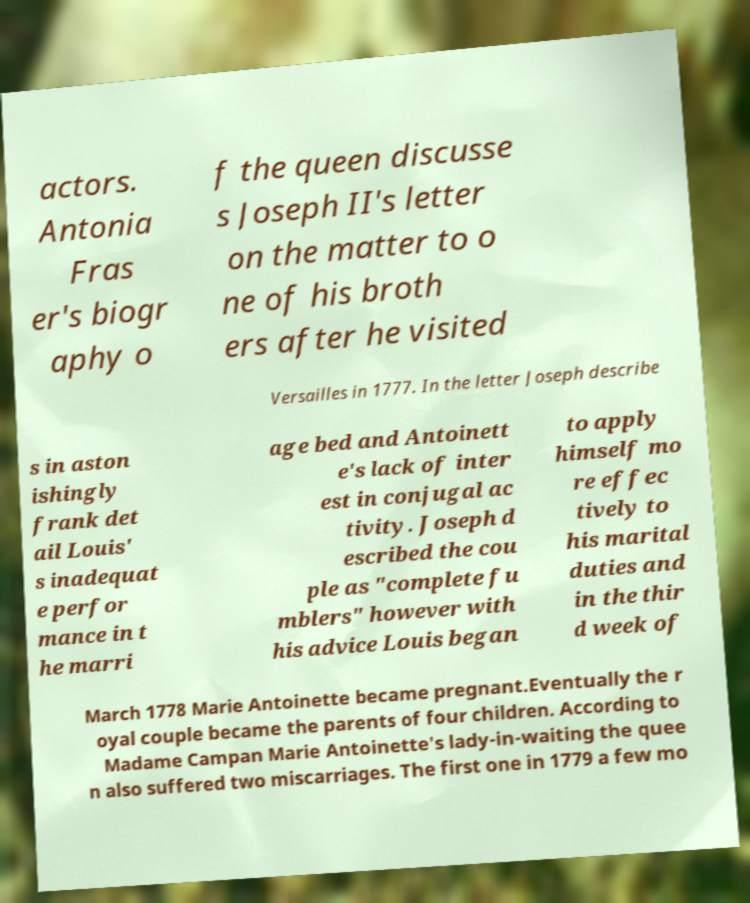There's text embedded in this image that I need extracted. Can you transcribe it verbatim? actors. Antonia Fras er's biogr aphy o f the queen discusse s Joseph II's letter on the matter to o ne of his broth ers after he visited Versailles in 1777. In the letter Joseph describe s in aston ishingly frank det ail Louis' s inadequat e perfor mance in t he marri age bed and Antoinett e's lack of inter est in conjugal ac tivity. Joseph d escribed the cou ple as "complete fu mblers" however with his advice Louis began to apply himself mo re effec tively to his marital duties and in the thir d week of March 1778 Marie Antoinette became pregnant.Eventually the r oyal couple became the parents of four children. According to Madame Campan Marie Antoinette's lady-in-waiting the quee n also suffered two miscarriages. The first one in 1779 a few mo 